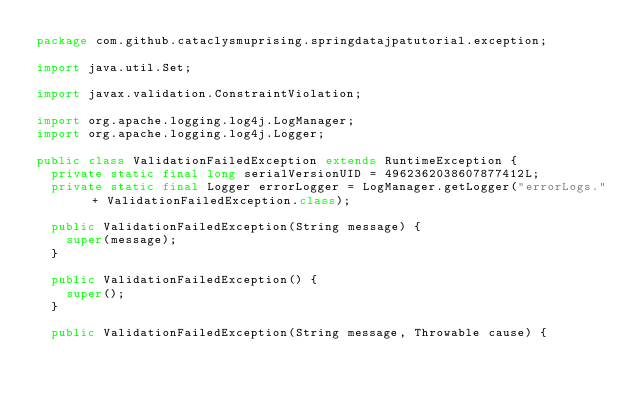Convert code to text. <code><loc_0><loc_0><loc_500><loc_500><_Java_>package com.github.cataclysmuprising.springdatajpatutorial.exception;

import java.util.Set;

import javax.validation.ConstraintViolation;

import org.apache.logging.log4j.LogManager;
import org.apache.logging.log4j.Logger;

public class ValidationFailedException extends RuntimeException {
	private static final long serialVersionUID = 4962362038607877412L;
	private static final Logger errorLogger = LogManager.getLogger("errorLogs." + ValidationFailedException.class);

	public ValidationFailedException(String message) {
		super(message);
	}

	public ValidationFailedException() {
		super();
	}

	public ValidationFailedException(String message, Throwable cause) {</code> 